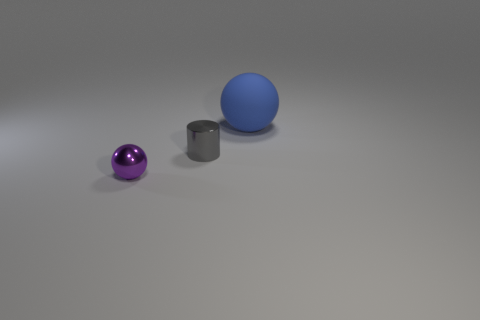There is a sphere that is to the left of the thing that is to the right of the gray cylinder; what is it made of?
Provide a succinct answer. Metal. Are there any large gray matte things?
Your answer should be very brief. No. There is a sphere that is behind the ball to the left of the matte object; what size is it?
Provide a succinct answer. Large. Are there more big things that are on the left side of the large blue thing than large matte spheres in front of the purple thing?
Keep it short and to the point. No. What number of balls are tiny gray objects or purple metallic things?
Give a very brief answer. 1. Is there anything else that is the same size as the metallic cylinder?
Offer a terse response. Yes. Is the shape of the small metal thing that is behind the small purple metallic thing the same as  the big object?
Offer a very short reply. No. The big thing is what color?
Ensure brevity in your answer.  Blue. There is a big rubber thing that is the same shape as the tiny purple shiny object; what color is it?
Make the answer very short. Blue. How many blue rubber things are the same shape as the purple thing?
Provide a short and direct response. 1. 